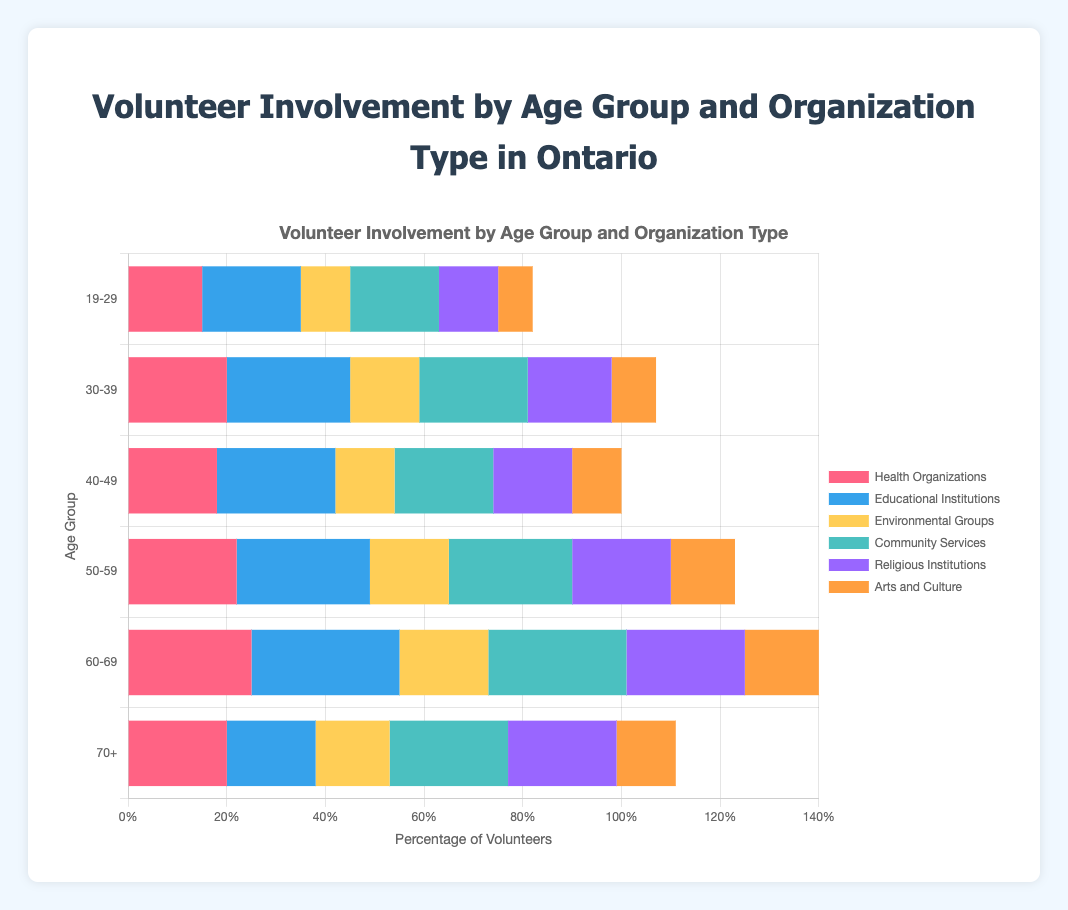Which age group has the highest involvement in Health Organizations? By looking at the bars for Health Organizations, the age group 60-69 has the longest bar, indicating the highest involvement.
Answer: 60-69 Which type of organization has the least involvement among the 19-29 age group? By comparing the lengths of bars for the 19-29 age group, the bar for Arts and Culture is shortest, indicating the least involvement.
Answer: Arts and Culture How does the volunteer involvement in Community Services compare between the 30-39 and 50-59 age groups? By comparing the lengths of the Community Services bars, 30-39 has a bar shorter than 50-59. Thus, volunteer involvement in Community Services is less for 30-39 compared to 50-59.
Answer: Less for 30-39 What is the sum of volunteers in Health Organizations and Educational Institutions for the 40-49 age group? The involvement in Health Organizations is 18 and in Educational Institutions is 24. Summing these up gives 18 + 24 = 42.
Answer: 42 Which organization type sees the most volunteer involvement from the 50-59 age group? Looking at the bars for the 50-59 age group, the longest bar is for Educational Institutions.
Answer: Educational Institutions Between the age groups 19-29 and 70+, which has a higher total involvement in community services and religious institutions? Sum each age group's involvement in these two categories (19-29: 18+12=30, 70+: 24+22=46). The 70+ age group has a higher total.
Answer: 70+ Which age group has the greatest difference in involvement between Educational Institutions and Environmental Groups, and what is that difference? Calculate the difference for each group and identify the max (19-29: 10, 30-39: 11, 40-49: 12, 50-59: 11, 60-69: 12, 70+: 3). Both 40-49 and 60-69 have the greatest difference of 12.
Answer: 40-49 and 60-69, 12 What is the average involvement in Environmental Groups across all age groups? Add involvement across age groups: 10+14+12+16+18+15=85. Dividing by 6 (number of age groups) gives 85/6 ≈ 14.17.
Answer: 14.17 